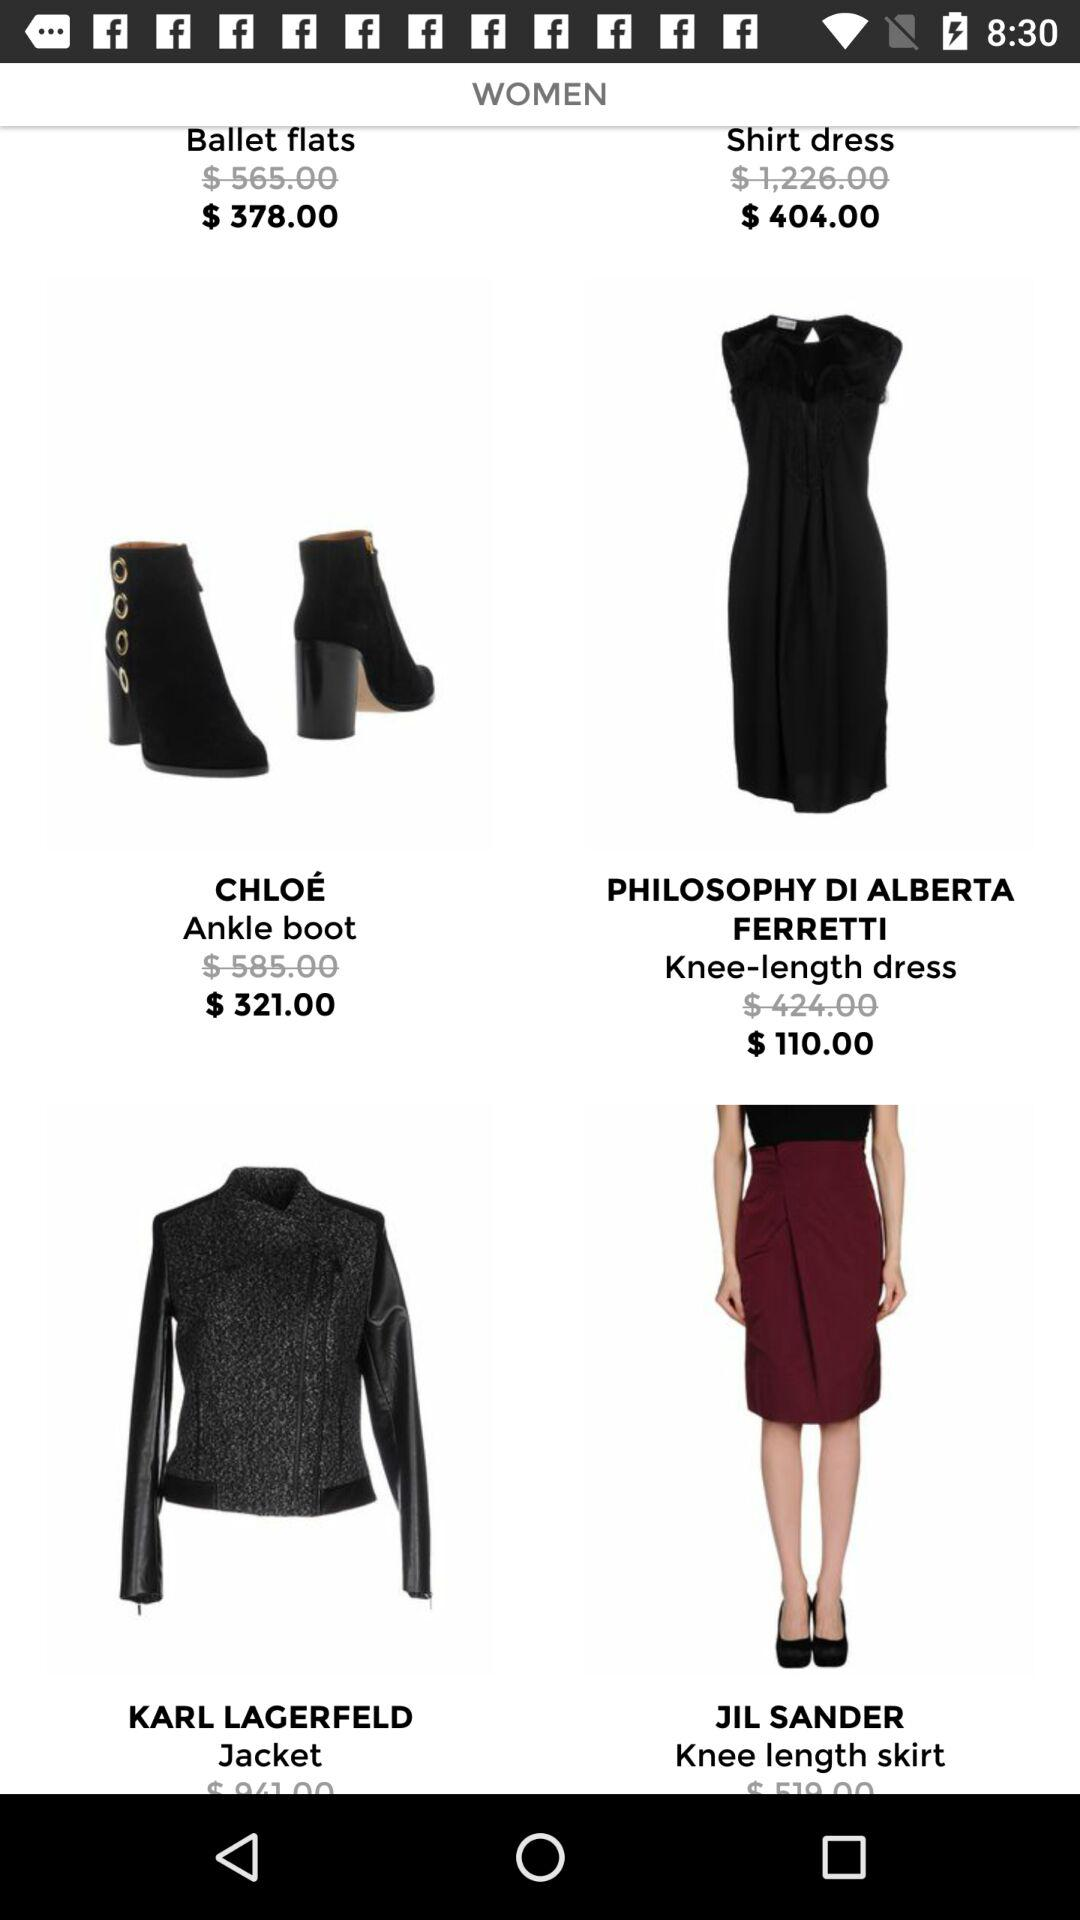What is the color of a knee length dress?
When the provided information is insufficient, respond with <no answer>. <no answer> 